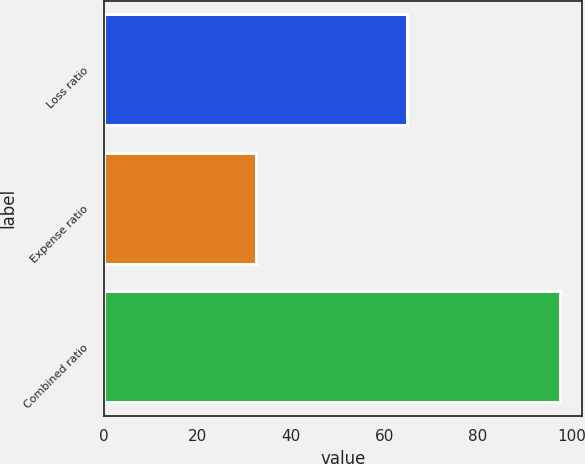Convert chart to OTSL. <chart><loc_0><loc_0><loc_500><loc_500><bar_chart><fcel>Loss ratio<fcel>Expense ratio<fcel>Combined ratio<nl><fcel>64.9<fcel>32.6<fcel>97.5<nl></chart> 